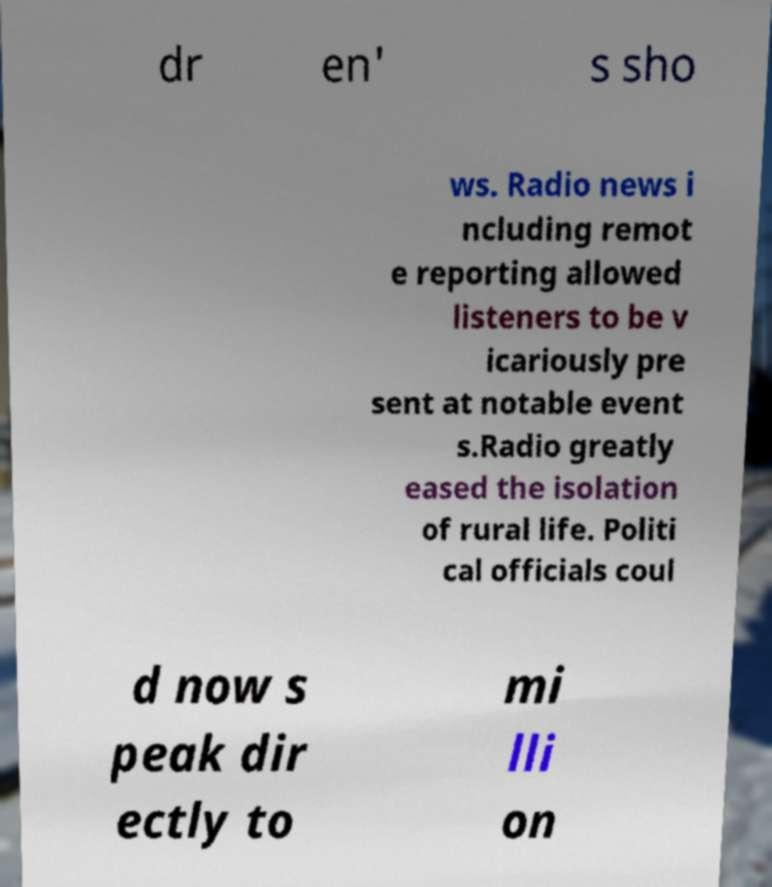Please identify and transcribe the text found in this image. dr en' s sho ws. Radio news i ncluding remot e reporting allowed listeners to be v icariously pre sent at notable event s.Radio greatly eased the isolation of rural life. Politi cal officials coul d now s peak dir ectly to mi lli on 